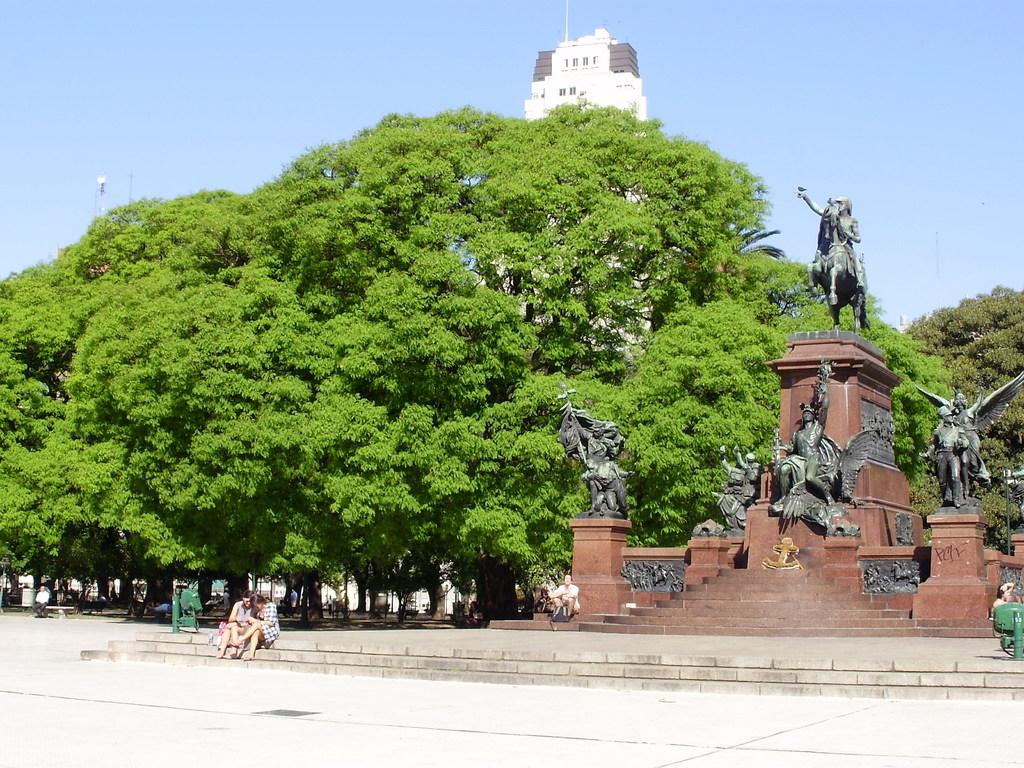What are the people in the image doing? The persons in the image are sitting on the stairs. What can be seen in the background of the image? There are trees, buildings, and statues in the background of the image. What type of seed is being planted by the persons sitting on the stairs? There is no seed or planting activity visible in the image. What type of lumber is being used to construct the statues in the background? There is no lumber or construction activity visible in the image; the statues are already present. 